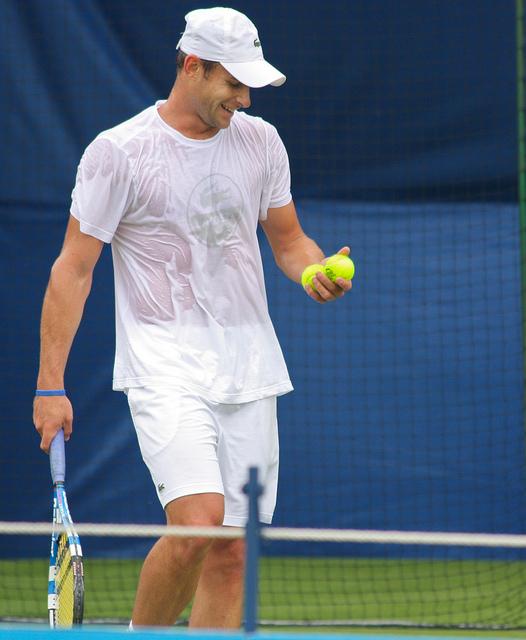Is the man sweaty?
Concise answer only. Yes. How many balls the man holding?
Concise answer only. 2. Is the man going to hit the ball?
Give a very brief answer. Yes. What game is the man playing?
Quick response, please. Tennis. 